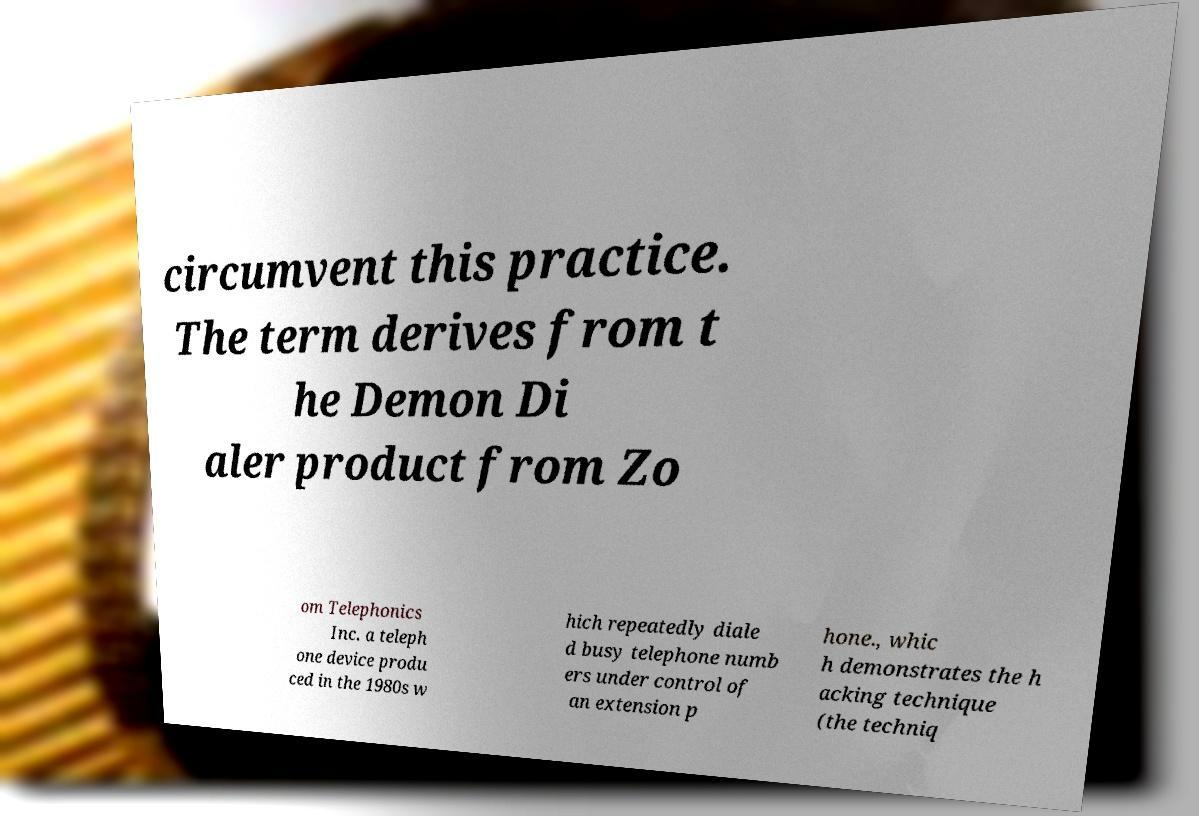Please identify and transcribe the text found in this image. circumvent this practice. The term derives from t he Demon Di aler product from Zo om Telephonics Inc. a teleph one device produ ced in the 1980s w hich repeatedly diale d busy telephone numb ers under control of an extension p hone., whic h demonstrates the h acking technique (the techniq 